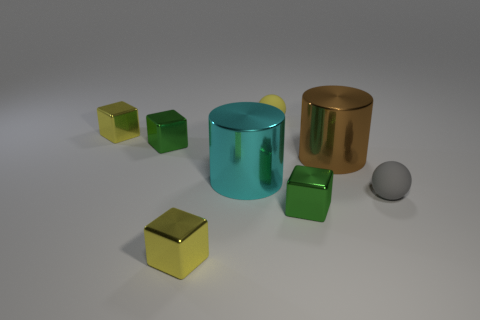Subtract all cyan blocks. Subtract all blue cylinders. How many blocks are left? 4 Add 1 yellow rubber spheres. How many objects exist? 9 Subtract all cylinders. How many objects are left? 6 Add 8 tiny green shiny blocks. How many tiny green shiny blocks exist? 10 Subtract 0 red cylinders. How many objects are left? 8 Subtract all yellow matte spheres. Subtract all tiny green metallic things. How many objects are left? 5 Add 8 large shiny cylinders. How many large shiny cylinders are left? 10 